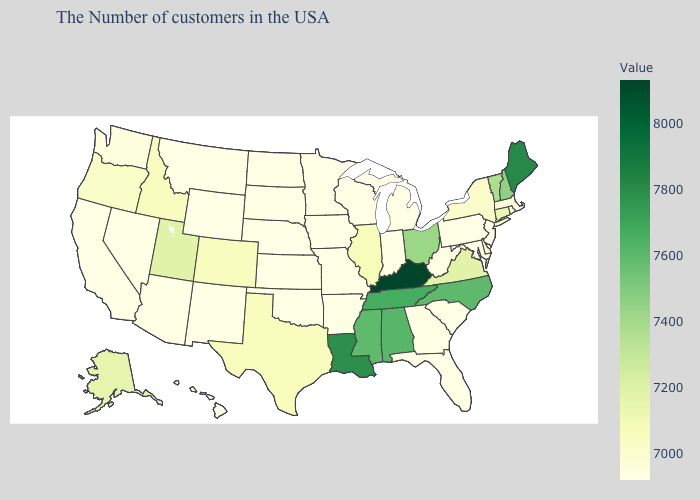Does Kentucky have the highest value in the USA?
Short answer required. Yes. Among the states that border Iowa , which have the highest value?
Be succinct. Illinois. Among the states that border Kentucky , does Illinois have the highest value?
Answer briefly. No. Is the legend a continuous bar?
Short answer required. Yes. Among the states that border Louisiana , does Arkansas have the highest value?
Quick response, please. No. Does Maine have the lowest value in the Northeast?
Answer briefly. No. Does the map have missing data?
Keep it brief. No. Among the states that border Nebraska , which have the lowest value?
Give a very brief answer. Missouri, Iowa, Kansas, South Dakota, Wyoming. 